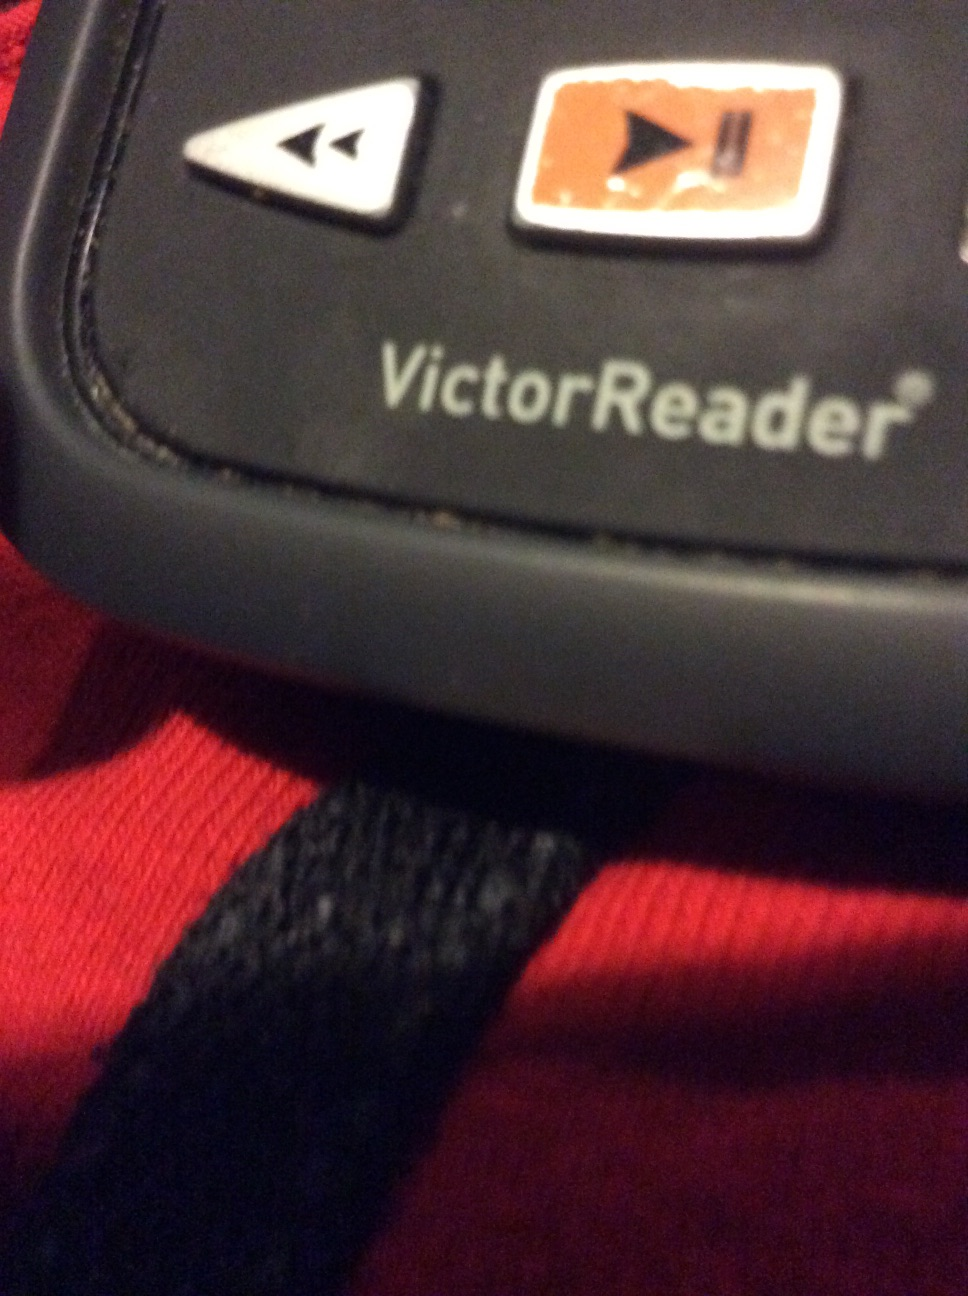How does the VictorReader function for someone who is visually impaired? The VictorReader functions by converting text into speech. Visually impaired users can navigate through texts using tactile buttons that have distinct shapes and positions. The device reads content out loud, providing an accessible way to experience written material without visual input. 